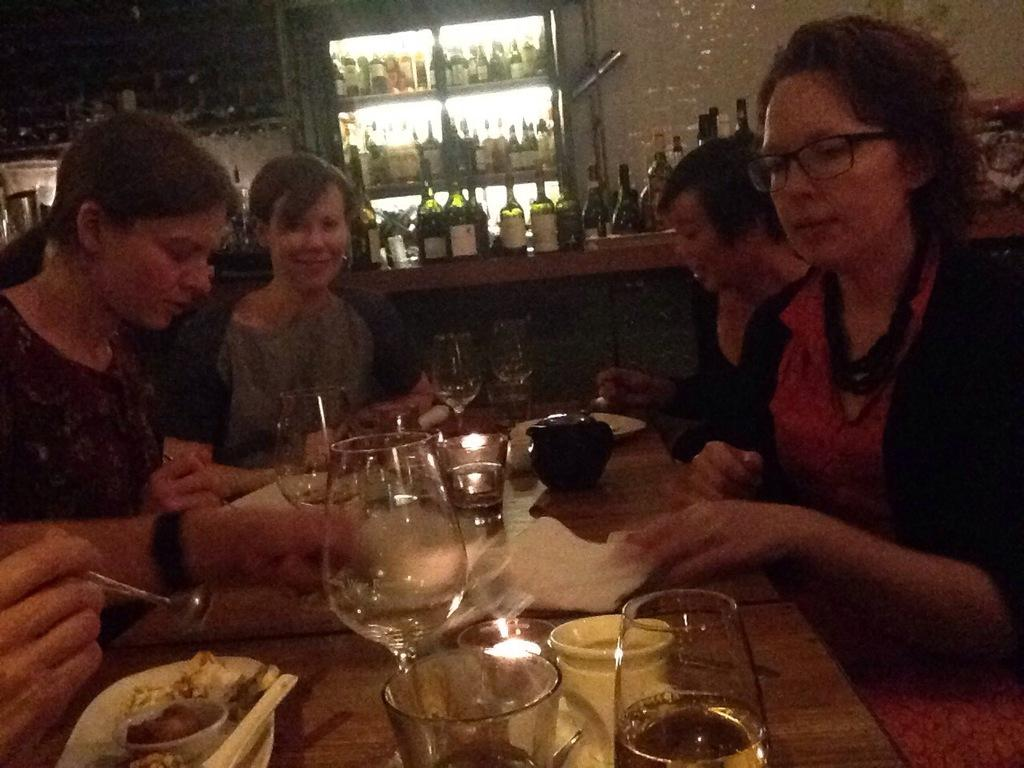What is happening in the image involving a group of people? There is a group of people sitting on a chair in the image. Where is the chair located in relation to other objects? The chair is in front of a table. What can be seen on the table? There are glasses and other objects on the table. How much sugar is being consumed by the people in the image? There is no information about sugar consumption in the image, as it only shows a group of people sitting on a chair and a table with glasses and other objects. 